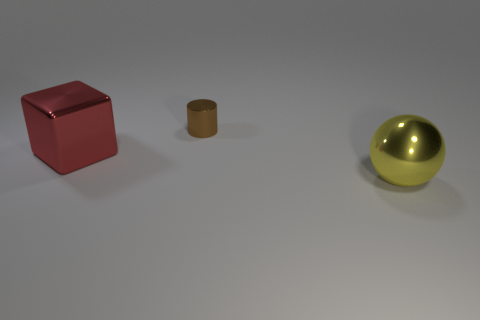If these objects were used in a game, what roles could they play? In a gaming context, the red cube might be an interactive puzzle piece or a collectible item, the small brown cylinder could serve as a container or a crafting resource, and the reflective gold sphere could be a key object for in-game progression, perhaps something that needs to be protected or used to unlock new levels or abilities. 